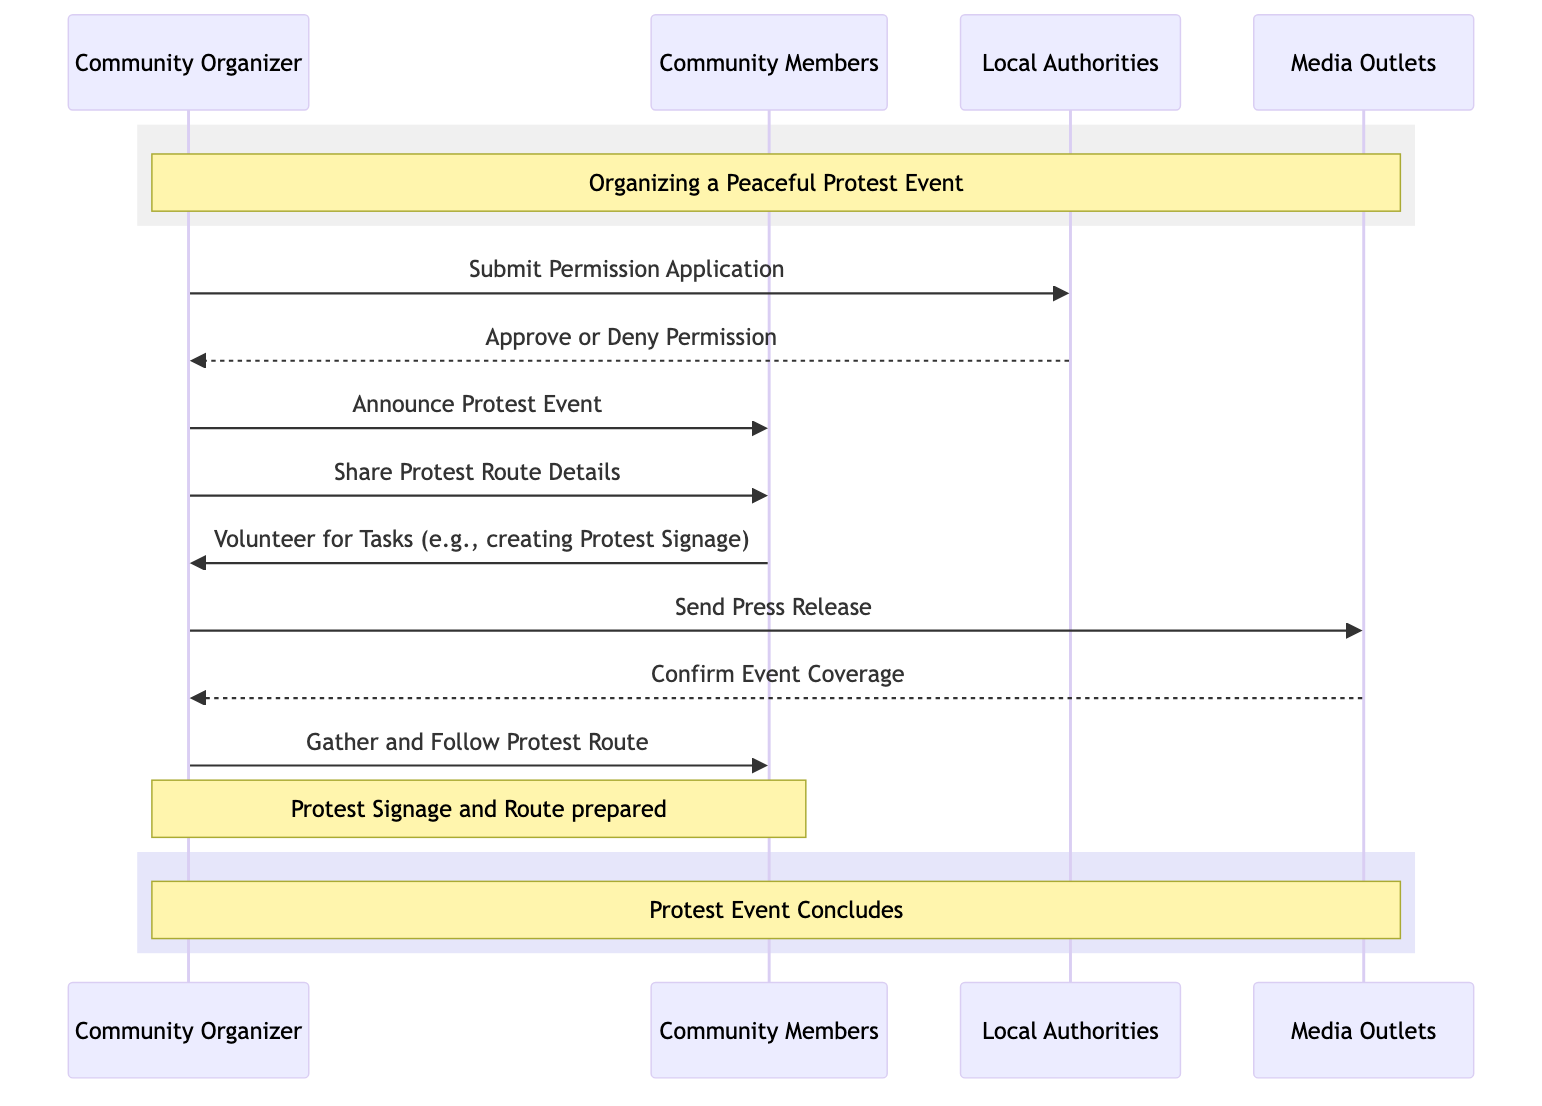What is the first action taken by the Community Organizer? The first action is "Submit Permission Application" which the Community Organizer does to initiate the process of organizing the protest event.
Answer: Submit Permission Application How many actors are involved in organizing the protest? There are four actors: Community Organizer, Community Members, Local Authorities, and Media Outlets, contributing to different roles in the event organization.
Answer: Four What message is sent to the Community Members after Local Authorities respond? After receiving the response from Local Authorities, the Community Organizer sends the message "Announce Protest Event" to the Community Members to inform them about the event's approval.
Answer: Announce Protest Event Which actor confirms the coverage of the event? The Media Outlets confirm the coverage of the event by sending a message back to the Community Organizer indicating their involvement in reporting on the protest.
Answer: Media Outlets What action do Community Members take regarding the protest signage? The Community Members communicate with the Community Organizer to "Volunteer for Tasks" which includes creating the protest signage, indicating their involvement and support.
Answer: Volunteer for Tasks (e.g., creating Protest Signage) What occurs after the Community Organizer sends the press release? Following the press release, the Media Outlets respond by confirming coverage for the protest event, signifying that they will report on it.
Answer: Confirm Event Coverage How many messages involve the Community Organizer sending information to others? There are five messages where the Community Organizer actively sends information to the Local Authorities, Community Members, and Media Outlets, demonstrating their coordinating role in the event.
Answer: Five What is prepared by the Community Organizer and Community Members? Both the Community Organizer and Community Members prepare the "Protest Signage and Route," indicating that they collaborate on essential materials for the protest.
Answer: Protest Signage and Route What is the final action that the Community Organizer instructs the Community Members to do? The final action is for the Community Members to "Gather and Follow Protest Route," which occurs as the protest event is about to take place.
Answer: Gather and Follow Protest Route 